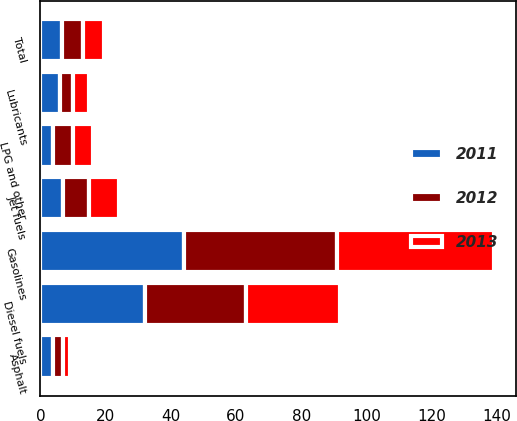<chart> <loc_0><loc_0><loc_500><loc_500><stacked_bar_chart><ecel><fcel>Gasolines<fcel>Diesel fuels<fcel>Jet fuels<fcel>Asphalt<fcel>Lubricants<fcel>LPG and other<fcel>Total<nl><fcel>2012<fcel>47<fcel>31<fcel>8<fcel>3<fcel>4<fcel>6<fcel>6.5<nl><fcel>2013<fcel>48<fcel>29<fcel>9<fcel>2<fcel>5<fcel>6<fcel>6.5<nl><fcel>2011<fcel>44<fcel>32<fcel>7<fcel>4<fcel>6<fcel>4<fcel>6.5<nl></chart> 